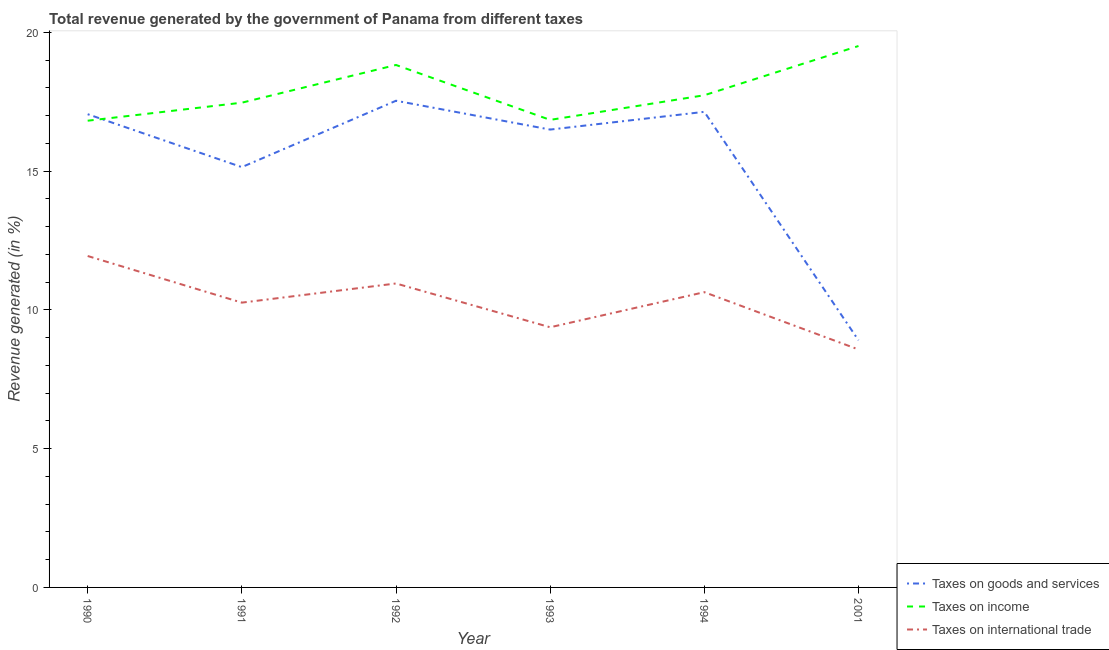What is the percentage of revenue generated by tax on international trade in 1990?
Offer a very short reply. 11.94. Across all years, what is the maximum percentage of revenue generated by taxes on goods and services?
Keep it short and to the point. 17.54. Across all years, what is the minimum percentage of revenue generated by taxes on income?
Your answer should be very brief. 16.82. In which year was the percentage of revenue generated by taxes on income minimum?
Make the answer very short. 1990. What is the total percentage of revenue generated by tax on international trade in the graph?
Give a very brief answer. 61.75. What is the difference between the percentage of revenue generated by taxes on income in 1991 and that in 1993?
Make the answer very short. 0.62. What is the difference between the percentage of revenue generated by taxes on income in 1991 and the percentage of revenue generated by tax on international trade in 1993?
Offer a very short reply. 8.09. What is the average percentage of revenue generated by taxes on income per year?
Make the answer very short. 17.87. In the year 1992, what is the difference between the percentage of revenue generated by taxes on income and percentage of revenue generated by taxes on goods and services?
Offer a very short reply. 1.29. What is the ratio of the percentage of revenue generated by taxes on income in 1991 to that in 1992?
Offer a very short reply. 0.93. Is the percentage of revenue generated by tax on international trade in 1990 less than that in 1991?
Your response must be concise. No. What is the difference between the highest and the second highest percentage of revenue generated by taxes on income?
Your answer should be compact. 0.68. What is the difference between the highest and the lowest percentage of revenue generated by taxes on income?
Offer a very short reply. 2.69. In how many years, is the percentage of revenue generated by tax on international trade greater than the average percentage of revenue generated by tax on international trade taken over all years?
Provide a succinct answer. 3. Is the sum of the percentage of revenue generated by taxes on goods and services in 1992 and 1994 greater than the maximum percentage of revenue generated by tax on international trade across all years?
Provide a succinct answer. Yes. Is the percentage of revenue generated by taxes on goods and services strictly greater than the percentage of revenue generated by taxes on income over the years?
Provide a succinct answer. No. How many lines are there?
Your response must be concise. 3. How many years are there in the graph?
Provide a succinct answer. 6. Does the graph contain any zero values?
Your answer should be very brief. No. How are the legend labels stacked?
Give a very brief answer. Vertical. What is the title of the graph?
Keep it short and to the point. Total revenue generated by the government of Panama from different taxes. Does "Private sector" appear as one of the legend labels in the graph?
Provide a short and direct response. No. What is the label or title of the X-axis?
Make the answer very short. Year. What is the label or title of the Y-axis?
Give a very brief answer. Revenue generated (in %). What is the Revenue generated (in %) in Taxes on goods and services in 1990?
Make the answer very short. 17.05. What is the Revenue generated (in %) of Taxes on income in 1990?
Your response must be concise. 16.82. What is the Revenue generated (in %) of Taxes on international trade in 1990?
Provide a short and direct response. 11.94. What is the Revenue generated (in %) of Taxes on goods and services in 1991?
Ensure brevity in your answer.  15.15. What is the Revenue generated (in %) in Taxes on income in 1991?
Make the answer very short. 17.47. What is the Revenue generated (in %) of Taxes on international trade in 1991?
Offer a terse response. 10.26. What is the Revenue generated (in %) of Taxes on goods and services in 1992?
Keep it short and to the point. 17.54. What is the Revenue generated (in %) in Taxes on income in 1992?
Ensure brevity in your answer.  18.83. What is the Revenue generated (in %) of Taxes on international trade in 1992?
Make the answer very short. 10.95. What is the Revenue generated (in %) in Taxes on goods and services in 1993?
Offer a very short reply. 16.5. What is the Revenue generated (in %) of Taxes on income in 1993?
Offer a terse response. 16.85. What is the Revenue generated (in %) of Taxes on international trade in 1993?
Provide a short and direct response. 9.38. What is the Revenue generated (in %) of Taxes on goods and services in 1994?
Offer a very short reply. 17.14. What is the Revenue generated (in %) of Taxes on income in 1994?
Give a very brief answer. 17.74. What is the Revenue generated (in %) of Taxes on international trade in 1994?
Make the answer very short. 10.64. What is the Revenue generated (in %) in Taxes on goods and services in 2001?
Offer a terse response. 8.91. What is the Revenue generated (in %) of Taxes on income in 2001?
Your answer should be very brief. 19.51. What is the Revenue generated (in %) in Taxes on international trade in 2001?
Your answer should be compact. 8.57. Across all years, what is the maximum Revenue generated (in %) of Taxes on goods and services?
Provide a short and direct response. 17.54. Across all years, what is the maximum Revenue generated (in %) of Taxes on income?
Make the answer very short. 19.51. Across all years, what is the maximum Revenue generated (in %) in Taxes on international trade?
Make the answer very short. 11.94. Across all years, what is the minimum Revenue generated (in %) of Taxes on goods and services?
Keep it short and to the point. 8.91. Across all years, what is the minimum Revenue generated (in %) in Taxes on income?
Your answer should be very brief. 16.82. Across all years, what is the minimum Revenue generated (in %) in Taxes on international trade?
Offer a very short reply. 8.57. What is the total Revenue generated (in %) of Taxes on goods and services in the graph?
Provide a succinct answer. 92.28. What is the total Revenue generated (in %) of Taxes on income in the graph?
Offer a very short reply. 107.21. What is the total Revenue generated (in %) of Taxes on international trade in the graph?
Offer a terse response. 61.75. What is the difference between the Revenue generated (in %) in Taxes on goods and services in 1990 and that in 1991?
Keep it short and to the point. 1.91. What is the difference between the Revenue generated (in %) in Taxes on income in 1990 and that in 1991?
Offer a very short reply. -0.65. What is the difference between the Revenue generated (in %) of Taxes on international trade in 1990 and that in 1991?
Your answer should be compact. 1.68. What is the difference between the Revenue generated (in %) of Taxes on goods and services in 1990 and that in 1992?
Make the answer very short. -0.48. What is the difference between the Revenue generated (in %) of Taxes on income in 1990 and that in 1992?
Provide a succinct answer. -2.01. What is the difference between the Revenue generated (in %) of Taxes on goods and services in 1990 and that in 1993?
Your answer should be very brief. 0.55. What is the difference between the Revenue generated (in %) of Taxes on income in 1990 and that in 1993?
Your answer should be very brief. -0.03. What is the difference between the Revenue generated (in %) in Taxes on international trade in 1990 and that in 1993?
Make the answer very short. 2.57. What is the difference between the Revenue generated (in %) of Taxes on goods and services in 1990 and that in 1994?
Ensure brevity in your answer.  -0.09. What is the difference between the Revenue generated (in %) of Taxes on income in 1990 and that in 1994?
Ensure brevity in your answer.  -0.92. What is the difference between the Revenue generated (in %) in Taxes on international trade in 1990 and that in 1994?
Your response must be concise. 1.3. What is the difference between the Revenue generated (in %) of Taxes on goods and services in 1990 and that in 2001?
Offer a very short reply. 8.15. What is the difference between the Revenue generated (in %) of Taxes on income in 1990 and that in 2001?
Your answer should be compact. -2.69. What is the difference between the Revenue generated (in %) in Taxes on international trade in 1990 and that in 2001?
Offer a terse response. 3.37. What is the difference between the Revenue generated (in %) of Taxes on goods and services in 1991 and that in 1992?
Offer a very short reply. -2.39. What is the difference between the Revenue generated (in %) in Taxes on income in 1991 and that in 1992?
Make the answer very short. -1.36. What is the difference between the Revenue generated (in %) in Taxes on international trade in 1991 and that in 1992?
Your response must be concise. -0.69. What is the difference between the Revenue generated (in %) in Taxes on goods and services in 1991 and that in 1993?
Provide a succinct answer. -1.35. What is the difference between the Revenue generated (in %) of Taxes on income in 1991 and that in 1993?
Offer a very short reply. 0.62. What is the difference between the Revenue generated (in %) in Taxes on international trade in 1991 and that in 1993?
Your answer should be very brief. 0.89. What is the difference between the Revenue generated (in %) of Taxes on goods and services in 1991 and that in 1994?
Give a very brief answer. -1.99. What is the difference between the Revenue generated (in %) of Taxes on income in 1991 and that in 1994?
Provide a succinct answer. -0.27. What is the difference between the Revenue generated (in %) of Taxes on international trade in 1991 and that in 1994?
Make the answer very short. -0.38. What is the difference between the Revenue generated (in %) in Taxes on goods and services in 1991 and that in 2001?
Ensure brevity in your answer.  6.24. What is the difference between the Revenue generated (in %) of Taxes on income in 1991 and that in 2001?
Provide a succinct answer. -2.04. What is the difference between the Revenue generated (in %) in Taxes on international trade in 1991 and that in 2001?
Give a very brief answer. 1.69. What is the difference between the Revenue generated (in %) of Taxes on goods and services in 1992 and that in 1993?
Offer a very short reply. 1.04. What is the difference between the Revenue generated (in %) in Taxes on income in 1992 and that in 1993?
Your answer should be compact. 1.98. What is the difference between the Revenue generated (in %) of Taxes on international trade in 1992 and that in 1993?
Give a very brief answer. 1.58. What is the difference between the Revenue generated (in %) in Taxes on goods and services in 1992 and that in 1994?
Offer a terse response. 0.4. What is the difference between the Revenue generated (in %) in Taxes on income in 1992 and that in 1994?
Your answer should be compact. 1.09. What is the difference between the Revenue generated (in %) in Taxes on international trade in 1992 and that in 1994?
Your response must be concise. 0.31. What is the difference between the Revenue generated (in %) of Taxes on goods and services in 1992 and that in 2001?
Give a very brief answer. 8.63. What is the difference between the Revenue generated (in %) in Taxes on income in 1992 and that in 2001?
Make the answer very short. -0.68. What is the difference between the Revenue generated (in %) of Taxes on international trade in 1992 and that in 2001?
Your answer should be very brief. 2.38. What is the difference between the Revenue generated (in %) in Taxes on goods and services in 1993 and that in 1994?
Offer a very short reply. -0.64. What is the difference between the Revenue generated (in %) in Taxes on income in 1993 and that in 1994?
Ensure brevity in your answer.  -0.89. What is the difference between the Revenue generated (in %) in Taxes on international trade in 1993 and that in 1994?
Offer a terse response. -1.26. What is the difference between the Revenue generated (in %) in Taxes on goods and services in 1993 and that in 2001?
Provide a succinct answer. 7.59. What is the difference between the Revenue generated (in %) in Taxes on income in 1993 and that in 2001?
Offer a very short reply. -2.66. What is the difference between the Revenue generated (in %) in Taxes on international trade in 1993 and that in 2001?
Make the answer very short. 0.8. What is the difference between the Revenue generated (in %) in Taxes on goods and services in 1994 and that in 2001?
Your answer should be compact. 8.23. What is the difference between the Revenue generated (in %) in Taxes on income in 1994 and that in 2001?
Your answer should be very brief. -1.77. What is the difference between the Revenue generated (in %) of Taxes on international trade in 1994 and that in 2001?
Make the answer very short. 2.07. What is the difference between the Revenue generated (in %) in Taxes on goods and services in 1990 and the Revenue generated (in %) in Taxes on income in 1991?
Make the answer very short. -0.42. What is the difference between the Revenue generated (in %) of Taxes on goods and services in 1990 and the Revenue generated (in %) of Taxes on international trade in 1991?
Make the answer very short. 6.79. What is the difference between the Revenue generated (in %) of Taxes on income in 1990 and the Revenue generated (in %) of Taxes on international trade in 1991?
Keep it short and to the point. 6.56. What is the difference between the Revenue generated (in %) in Taxes on goods and services in 1990 and the Revenue generated (in %) in Taxes on income in 1992?
Offer a terse response. -1.77. What is the difference between the Revenue generated (in %) in Taxes on goods and services in 1990 and the Revenue generated (in %) in Taxes on international trade in 1992?
Offer a very short reply. 6.1. What is the difference between the Revenue generated (in %) in Taxes on income in 1990 and the Revenue generated (in %) in Taxes on international trade in 1992?
Ensure brevity in your answer.  5.87. What is the difference between the Revenue generated (in %) in Taxes on goods and services in 1990 and the Revenue generated (in %) in Taxes on income in 1993?
Provide a succinct answer. 0.2. What is the difference between the Revenue generated (in %) of Taxes on goods and services in 1990 and the Revenue generated (in %) of Taxes on international trade in 1993?
Provide a short and direct response. 7.68. What is the difference between the Revenue generated (in %) in Taxes on income in 1990 and the Revenue generated (in %) in Taxes on international trade in 1993?
Provide a short and direct response. 7.44. What is the difference between the Revenue generated (in %) of Taxes on goods and services in 1990 and the Revenue generated (in %) of Taxes on income in 1994?
Offer a very short reply. -0.68. What is the difference between the Revenue generated (in %) of Taxes on goods and services in 1990 and the Revenue generated (in %) of Taxes on international trade in 1994?
Make the answer very short. 6.41. What is the difference between the Revenue generated (in %) of Taxes on income in 1990 and the Revenue generated (in %) of Taxes on international trade in 1994?
Offer a very short reply. 6.18. What is the difference between the Revenue generated (in %) of Taxes on goods and services in 1990 and the Revenue generated (in %) of Taxes on income in 2001?
Ensure brevity in your answer.  -2.46. What is the difference between the Revenue generated (in %) in Taxes on goods and services in 1990 and the Revenue generated (in %) in Taxes on international trade in 2001?
Offer a terse response. 8.48. What is the difference between the Revenue generated (in %) in Taxes on income in 1990 and the Revenue generated (in %) in Taxes on international trade in 2001?
Keep it short and to the point. 8.24. What is the difference between the Revenue generated (in %) in Taxes on goods and services in 1991 and the Revenue generated (in %) in Taxes on income in 1992?
Give a very brief answer. -3.68. What is the difference between the Revenue generated (in %) of Taxes on goods and services in 1991 and the Revenue generated (in %) of Taxes on international trade in 1992?
Offer a terse response. 4.19. What is the difference between the Revenue generated (in %) of Taxes on income in 1991 and the Revenue generated (in %) of Taxes on international trade in 1992?
Offer a very short reply. 6.51. What is the difference between the Revenue generated (in %) in Taxes on goods and services in 1991 and the Revenue generated (in %) in Taxes on income in 1993?
Your answer should be very brief. -1.7. What is the difference between the Revenue generated (in %) of Taxes on goods and services in 1991 and the Revenue generated (in %) of Taxes on international trade in 1993?
Give a very brief answer. 5.77. What is the difference between the Revenue generated (in %) of Taxes on income in 1991 and the Revenue generated (in %) of Taxes on international trade in 1993?
Make the answer very short. 8.09. What is the difference between the Revenue generated (in %) of Taxes on goods and services in 1991 and the Revenue generated (in %) of Taxes on income in 1994?
Keep it short and to the point. -2.59. What is the difference between the Revenue generated (in %) in Taxes on goods and services in 1991 and the Revenue generated (in %) in Taxes on international trade in 1994?
Ensure brevity in your answer.  4.51. What is the difference between the Revenue generated (in %) in Taxes on income in 1991 and the Revenue generated (in %) in Taxes on international trade in 1994?
Keep it short and to the point. 6.83. What is the difference between the Revenue generated (in %) of Taxes on goods and services in 1991 and the Revenue generated (in %) of Taxes on income in 2001?
Give a very brief answer. -4.36. What is the difference between the Revenue generated (in %) of Taxes on goods and services in 1991 and the Revenue generated (in %) of Taxes on international trade in 2001?
Your response must be concise. 6.57. What is the difference between the Revenue generated (in %) of Taxes on income in 1991 and the Revenue generated (in %) of Taxes on international trade in 2001?
Your answer should be very brief. 8.89. What is the difference between the Revenue generated (in %) in Taxes on goods and services in 1992 and the Revenue generated (in %) in Taxes on income in 1993?
Ensure brevity in your answer.  0.69. What is the difference between the Revenue generated (in %) of Taxes on goods and services in 1992 and the Revenue generated (in %) of Taxes on international trade in 1993?
Offer a terse response. 8.16. What is the difference between the Revenue generated (in %) of Taxes on income in 1992 and the Revenue generated (in %) of Taxes on international trade in 1993?
Your answer should be very brief. 9.45. What is the difference between the Revenue generated (in %) of Taxes on goods and services in 1992 and the Revenue generated (in %) of Taxes on income in 1994?
Your answer should be compact. -0.2. What is the difference between the Revenue generated (in %) of Taxes on goods and services in 1992 and the Revenue generated (in %) of Taxes on international trade in 1994?
Offer a very short reply. 6.9. What is the difference between the Revenue generated (in %) of Taxes on income in 1992 and the Revenue generated (in %) of Taxes on international trade in 1994?
Offer a very short reply. 8.19. What is the difference between the Revenue generated (in %) of Taxes on goods and services in 1992 and the Revenue generated (in %) of Taxes on income in 2001?
Your answer should be compact. -1.97. What is the difference between the Revenue generated (in %) in Taxes on goods and services in 1992 and the Revenue generated (in %) in Taxes on international trade in 2001?
Your answer should be compact. 8.96. What is the difference between the Revenue generated (in %) in Taxes on income in 1992 and the Revenue generated (in %) in Taxes on international trade in 2001?
Offer a terse response. 10.25. What is the difference between the Revenue generated (in %) of Taxes on goods and services in 1993 and the Revenue generated (in %) of Taxes on income in 1994?
Offer a terse response. -1.24. What is the difference between the Revenue generated (in %) of Taxes on goods and services in 1993 and the Revenue generated (in %) of Taxes on international trade in 1994?
Offer a terse response. 5.86. What is the difference between the Revenue generated (in %) of Taxes on income in 1993 and the Revenue generated (in %) of Taxes on international trade in 1994?
Your response must be concise. 6.21. What is the difference between the Revenue generated (in %) of Taxes on goods and services in 1993 and the Revenue generated (in %) of Taxes on income in 2001?
Your answer should be very brief. -3.01. What is the difference between the Revenue generated (in %) of Taxes on goods and services in 1993 and the Revenue generated (in %) of Taxes on international trade in 2001?
Your answer should be compact. 7.92. What is the difference between the Revenue generated (in %) in Taxes on income in 1993 and the Revenue generated (in %) in Taxes on international trade in 2001?
Your answer should be compact. 8.27. What is the difference between the Revenue generated (in %) of Taxes on goods and services in 1994 and the Revenue generated (in %) of Taxes on income in 2001?
Ensure brevity in your answer.  -2.37. What is the difference between the Revenue generated (in %) of Taxes on goods and services in 1994 and the Revenue generated (in %) of Taxes on international trade in 2001?
Ensure brevity in your answer.  8.56. What is the difference between the Revenue generated (in %) in Taxes on income in 1994 and the Revenue generated (in %) in Taxes on international trade in 2001?
Give a very brief answer. 9.16. What is the average Revenue generated (in %) of Taxes on goods and services per year?
Keep it short and to the point. 15.38. What is the average Revenue generated (in %) of Taxes on income per year?
Your answer should be compact. 17.87. What is the average Revenue generated (in %) in Taxes on international trade per year?
Offer a very short reply. 10.29. In the year 1990, what is the difference between the Revenue generated (in %) in Taxes on goods and services and Revenue generated (in %) in Taxes on income?
Your answer should be very brief. 0.23. In the year 1990, what is the difference between the Revenue generated (in %) in Taxes on goods and services and Revenue generated (in %) in Taxes on international trade?
Your answer should be compact. 5.11. In the year 1990, what is the difference between the Revenue generated (in %) in Taxes on income and Revenue generated (in %) in Taxes on international trade?
Give a very brief answer. 4.88. In the year 1991, what is the difference between the Revenue generated (in %) in Taxes on goods and services and Revenue generated (in %) in Taxes on income?
Offer a terse response. -2.32. In the year 1991, what is the difference between the Revenue generated (in %) in Taxes on goods and services and Revenue generated (in %) in Taxes on international trade?
Offer a very short reply. 4.88. In the year 1991, what is the difference between the Revenue generated (in %) in Taxes on income and Revenue generated (in %) in Taxes on international trade?
Your answer should be compact. 7.21. In the year 1992, what is the difference between the Revenue generated (in %) in Taxes on goods and services and Revenue generated (in %) in Taxes on income?
Provide a short and direct response. -1.29. In the year 1992, what is the difference between the Revenue generated (in %) in Taxes on goods and services and Revenue generated (in %) in Taxes on international trade?
Your answer should be very brief. 6.58. In the year 1992, what is the difference between the Revenue generated (in %) in Taxes on income and Revenue generated (in %) in Taxes on international trade?
Ensure brevity in your answer.  7.87. In the year 1993, what is the difference between the Revenue generated (in %) in Taxes on goods and services and Revenue generated (in %) in Taxes on income?
Your answer should be compact. -0.35. In the year 1993, what is the difference between the Revenue generated (in %) in Taxes on goods and services and Revenue generated (in %) in Taxes on international trade?
Provide a short and direct response. 7.12. In the year 1993, what is the difference between the Revenue generated (in %) of Taxes on income and Revenue generated (in %) of Taxes on international trade?
Keep it short and to the point. 7.47. In the year 1994, what is the difference between the Revenue generated (in %) in Taxes on goods and services and Revenue generated (in %) in Taxes on income?
Give a very brief answer. -0.6. In the year 1994, what is the difference between the Revenue generated (in %) in Taxes on goods and services and Revenue generated (in %) in Taxes on international trade?
Offer a terse response. 6.5. In the year 1994, what is the difference between the Revenue generated (in %) in Taxes on income and Revenue generated (in %) in Taxes on international trade?
Your response must be concise. 7.1. In the year 2001, what is the difference between the Revenue generated (in %) of Taxes on goods and services and Revenue generated (in %) of Taxes on income?
Provide a succinct answer. -10.6. In the year 2001, what is the difference between the Revenue generated (in %) of Taxes on goods and services and Revenue generated (in %) of Taxes on international trade?
Keep it short and to the point. 0.33. In the year 2001, what is the difference between the Revenue generated (in %) of Taxes on income and Revenue generated (in %) of Taxes on international trade?
Provide a succinct answer. 10.94. What is the ratio of the Revenue generated (in %) of Taxes on goods and services in 1990 to that in 1991?
Your answer should be compact. 1.13. What is the ratio of the Revenue generated (in %) in Taxes on income in 1990 to that in 1991?
Provide a short and direct response. 0.96. What is the ratio of the Revenue generated (in %) of Taxes on international trade in 1990 to that in 1991?
Provide a short and direct response. 1.16. What is the ratio of the Revenue generated (in %) in Taxes on goods and services in 1990 to that in 1992?
Provide a short and direct response. 0.97. What is the ratio of the Revenue generated (in %) in Taxes on income in 1990 to that in 1992?
Your response must be concise. 0.89. What is the ratio of the Revenue generated (in %) in Taxes on international trade in 1990 to that in 1992?
Keep it short and to the point. 1.09. What is the ratio of the Revenue generated (in %) in Taxes on goods and services in 1990 to that in 1993?
Provide a short and direct response. 1.03. What is the ratio of the Revenue generated (in %) of Taxes on international trade in 1990 to that in 1993?
Provide a short and direct response. 1.27. What is the ratio of the Revenue generated (in %) in Taxes on income in 1990 to that in 1994?
Your answer should be compact. 0.95. What is the ratio of the Revenue generated (in %) of Taxes on international trade in 1990 to that in 1994?
Your answer should be very brief. 1.12. What is the ratio of the Revenue generated (in %) in Taxes on goods and services in 1990 to that in 2001?
Offer a very short reply. 1.91. What is the ratio of the Revenue generated (in %) in Taxes on income in 1990 to that in 2001?
Make the answer very short. 0.86. What is the ratio of the Revenue generated (in %) in Taxes on international trade in 1990 to that in 2001?
Your answer should be very brief. 1.39. What is the ratio of the Revenue generated (in %) of Taxes on goods and services in 1991 to that in 1992?
Offer a terse response. 0.86. What is the ratio of the Revenue generated (in %) in Taxes on income in 1991 to that in 1992?
Provide a succinct answer. 0.93. What is the ratio of the Revenue generated (in %) in Taxes on international trade in 1991 to that in 1992?
Provide a succinct answer. 0.94. What is the ratio of the Revenue generated (in %) of Taxes on goods and services in 1991 to that in 1993?
Your response must be concise. 0.92. What is the ratio of the Revenue generated (in %) of Taxes on income in 1991 to that in 1993?
Give a very brief answer. 1.04. What is the ratio of the Revenue generated (in %) of Taxes on international trade in 1991 to that in 1993?
Keep it short and to the point. 1.09. What is the ratio of the Revenue generated (in %) of Taxes on goods and services in 1991 to that in 1994?
Give a very brief answer. 0.88. What is the ratio of the Revenue generated (in %) in Taxes on income in 1991 to that in 1994?
Your answer should be compact. 0.98. What is the ratio of the Revenue generated (in %) in Taxes on international trade in 1991 to that in 1994?
Provide a succinct answer. 0.96. What is the ratio of the Revenue generated (in %) in Taxes on goods and services in 1991 to that in 2001?
Offer a terse response. 1.7. What is the ratio of the Revenue generated (in %) in Taxes on income in 1991 to that in 2001?
Make the answer very short. 0.9. What is the ratio of the Revenue generated (in %) in Taxes on international trade in 1991 to that in 2001?
Provide a short and direct response. 1.2. What is the ratio of the Revenue generated (in %) of Taxes on goods and services in 1992 to that in 1993?
Offer a terse response. 1.06. What is the ratio of the Revenue generated (in %) in Taxes on income in 1992 to that in 1993?
Keep it short and to the point. 1.12. What is the ratio of the Revenue generated (in %) of Taxes on international trade in 1992 to that in 1993?
Provide a succinct answer. 1.17. What is the ratio of the Revenue generated (in %) in Taxes on goods and services in 1992 to that in 1994?
Keep it short and to the point. 1.02. What is the ratio of the Revenue generated (in %) in Taxes on income in 1992 to that in 1994?
Your response must be concise. 1.06. What is the ratio of the Revenue generated (in %) in Taxes on international trade in 1992 to that in 1994?
Give a very brief answer. 1.03. What is the ratio of the Revenue generated (in %) in Taxes on goods and services in 1992 to that in 2001?
Provide a short and direct response. 1.97. What is the ratio of the Revenue generated (in %) of Taxes on income in 1992 to that in 2001?
Make the answer very short. 0.96. What is the ratio of the Revenue generated (in %) of Taxes on international trade in 1992 to that in 2001?
Offer a terse response. 1.28. What is the ratio of the Revenue generated (in %) in Taxes on goods and services in 1993 to that in 1994?
Keep it short and to the point. 0.96. What is the ratio of the Revenue generated (in %) in Taxes on income in 1993 to that in 1994?
Give a very brief answer. 0.95. What is the ratio of the Revenue generated (in %) of Taxes on international trade in 1993 to that in 1994?
Provide a succinct answer. 0.88. What is the ratio of the Revenue generated (in %) of Taxes on goods and services in 1993 to that in 2001?
Give a very brief answer. 1.85. What is the ratio of the Revenue generated (in %) in Taxes on income in 1993 to that in 2001?
Your response must be concise. 0.86. What is the ratio of the Revenue generated (in %) of Taxes on international trade in 1993 to that in 2001?
Make the answer very short. 1.09. What is the ratio of the Revenue generated (in %) of Taxes on goods and services in 1994 to that in 2001?
Offer a very short reply. 1.92. What is the ratio of the Revenue generated (in %) of Taxes on international trade in 1994 to that in 2001?
Your answer should be very brief. 1.24. What is the difference between the highest and the second highest Revenue generated (in %) of Taxes on goods and services?
Ensure brevity in your answer.  0.4. What is the difference between the highest and the second highest Revenue generated (in %) of Taxes on income?
Your response must be concise. 0.68. What is the difference between the highest and the second highest Revenue generated (in %) in Taxes on international trade?
Offer a very short reply. 0.99. What is the difference between the highest and the lowest Revenue generated (in %) of Taxes on goods and services?
Your answer should be very brief. 8.63. What is the difference between the highest and the lowest Revenue generated (in %) in Taxes on income?
Give a very brief answer. 2.69. What is the difference between the highest and the lowest Revenue generated (in %) of Taxes on international trade?
Offer a terse response. 3.37. 